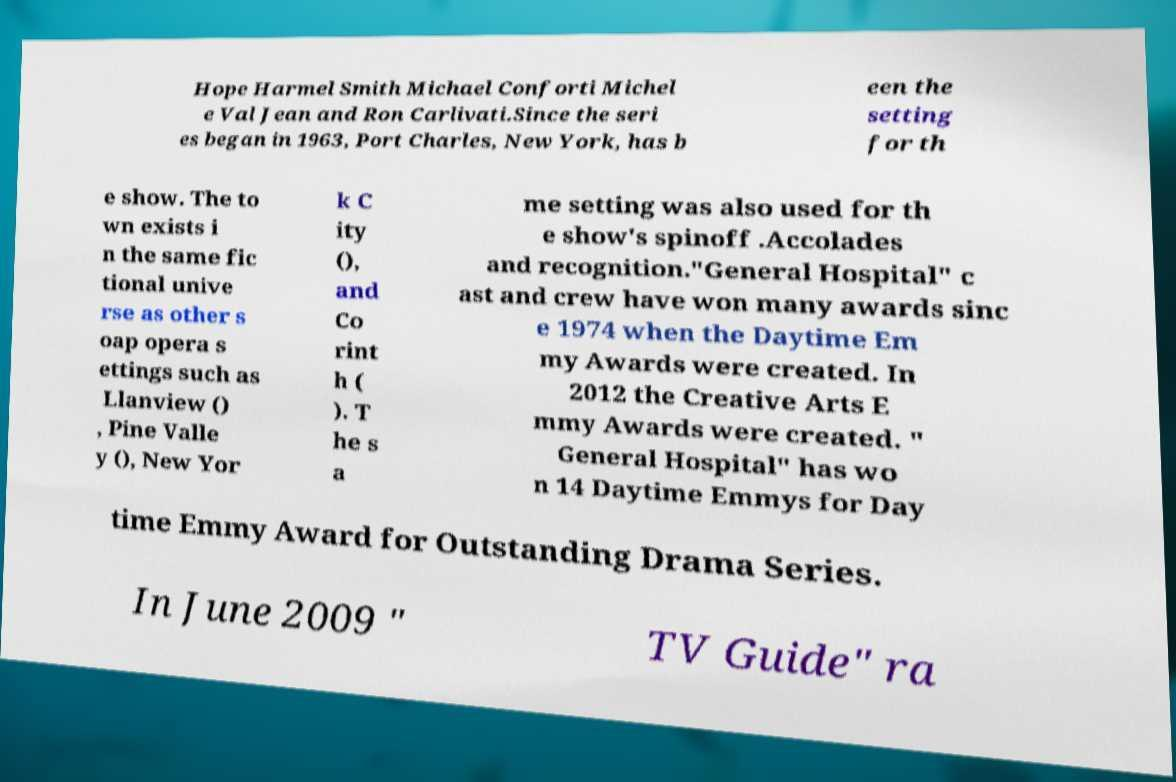Please read and relay the text visible in this image. What does it say? Hope Harmel Smith Michael Conforti Michel e Val Jean and Ron Carlivati.Since the seri es began in 1963, Port Charles, New York, has b een the setting for th e show. The to wn exists i n the same fic tional unive rse as other s oap opera s ettings such as Llanview () , Pine Valle y (), New Yor k C ity (), and Co rint h ( ). T he s a me setting was also used for th e show's spinoff .Accolades and recognition."General Hospital" c ast and crew have won many awards sinc e 1974 when the Daytime Em my Awards were created. In 2012 the Creative Arts E mmy Awards were created. " General Hospital" has wo n 14 Daytime Emmys for Day time Emmy Award for Outstanding Drama Series. In June 2009 " TV Guide" ra 